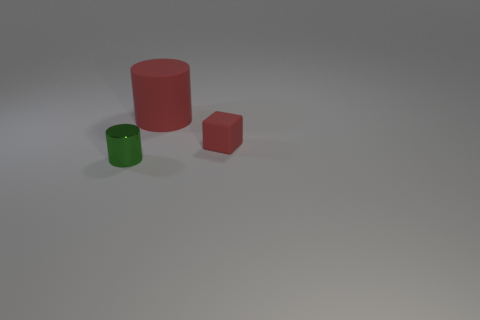Add 1 tiny metallic things. How many objects exist? 4 Subtract all red cylinders. How many cylinders are left? 1 Subtract 1 green cylinders. How many objects are left? 2 Subtract all cylinders. How many objects are left? 1 Subtract 2 cylinders. How many cylinders are left? 0 Subtract all brown cylinders. Subtract all purple blocks. How many cylinders are left? 2 Subtract all green cylinders. How many blue blocks are left? 0 Subtract all big cyan matte balls. Subtract all big things. How many objects are left? 2 Add 1 shiny things. How many shiny things are left? 2 Add 2 rubber cubes. How many rubber cubes exist? 3 